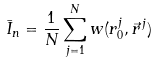<formula> <loc_0><loc_0><loc_500><loc_500>\bar { I } _ { n } = \frac { 1 } { N } \sum _ { j = 1 } ^ { N } w ( r _ { 0 } ^ { j } , \vec { r } ^ { \, j } )</formula> 